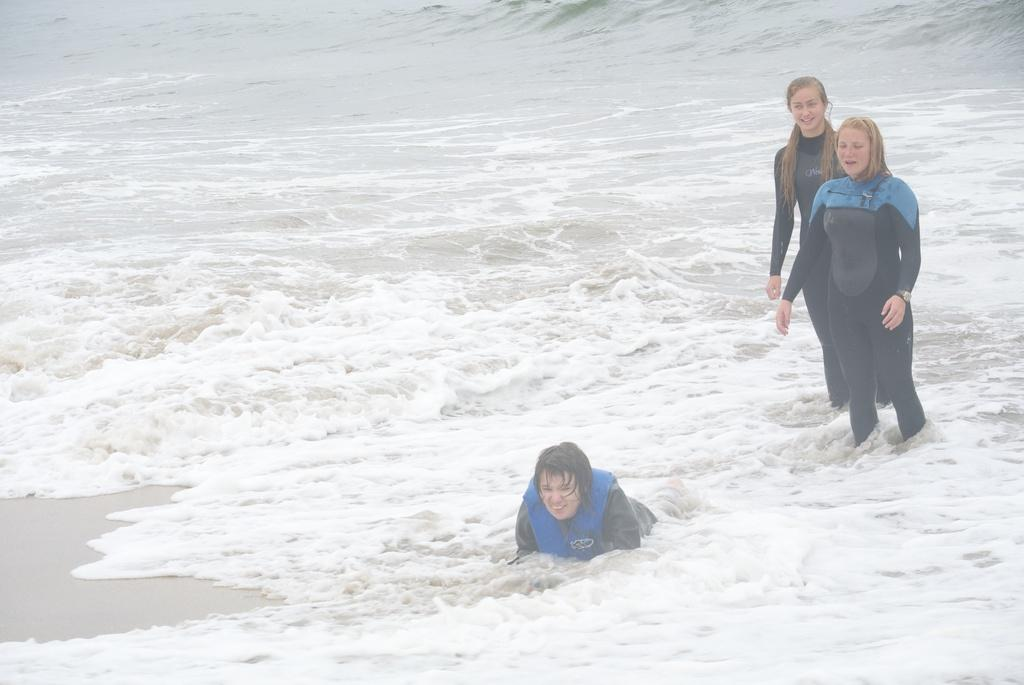How many people are present in the image? There are three women in the image. What can be seen in the background of the image? There is water visible in the background of the image. What type of curtain can be seen in the image? There is no curtain present in the image. What position do the women hold in the image? The image does not provide information about the positions or roles of the women. 